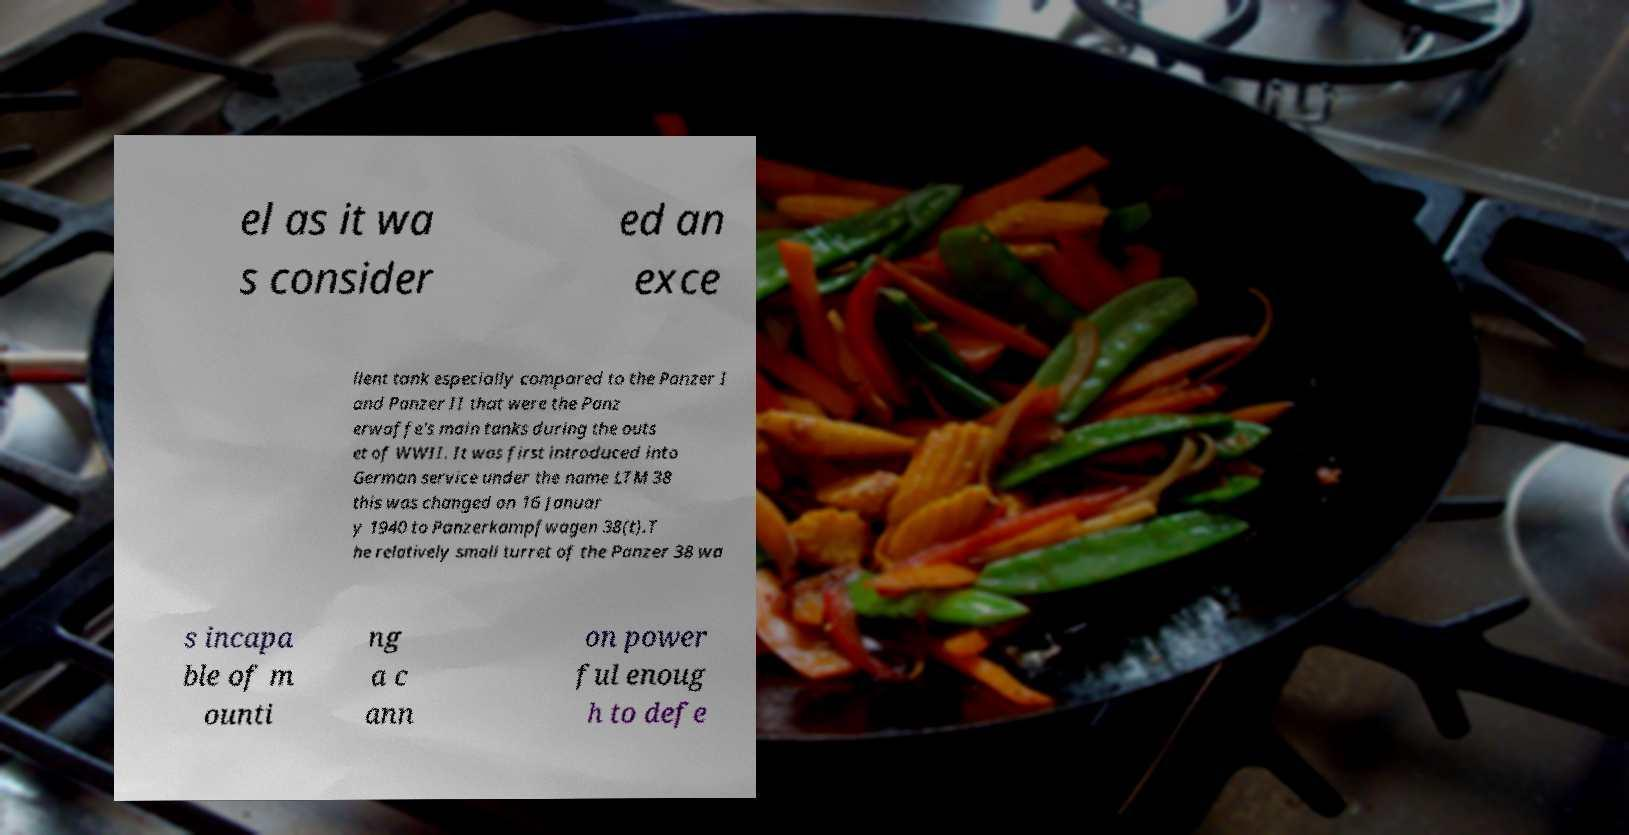I need the written content from this picture converted into text. Can you do that? el as it wa s consider ed an exce llent tank especially compared to the Panzer I and Panzer II that were the Panz erwaffe's main tanks during the outs et of WWII. It was first introduced into German service under the name LTM 38 this was changed on 16 Januar y 1940 to Panzerkampfwagen 38(t).T he relatively small turret of the Panzer 38 wa s incapa ble of m ounti ng a c ann on power ful enoug h to defe 